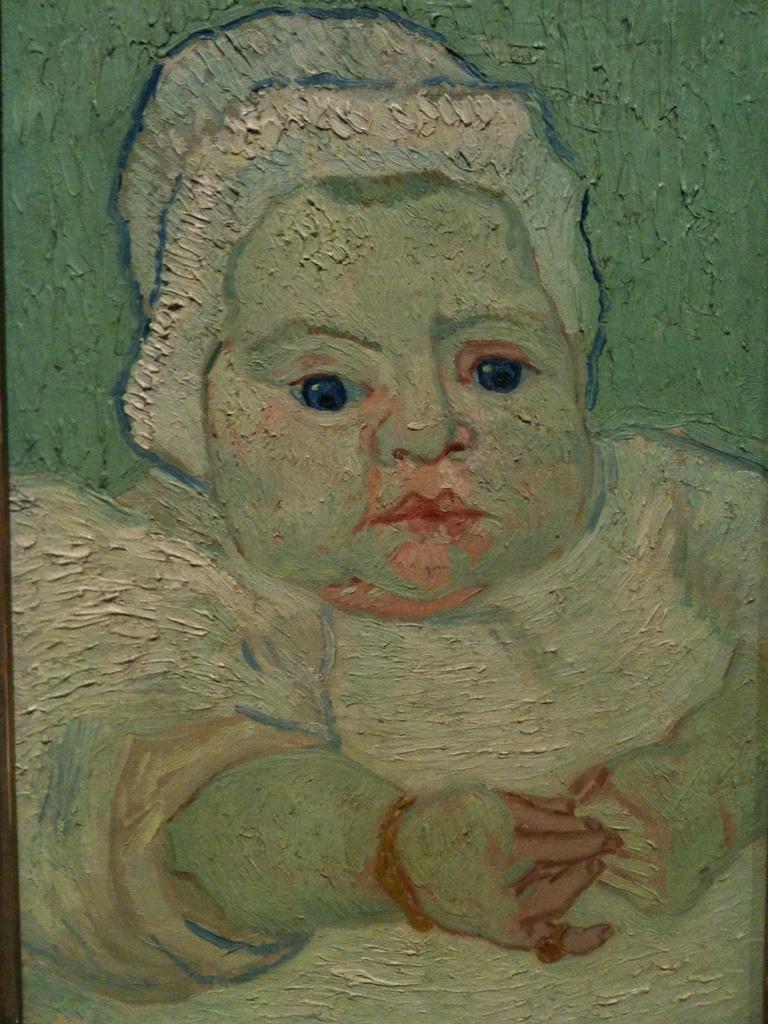Could you give a brief overview of what you see in this image? In this image, we can see a painting of a kid. In the background, we can see green color. 